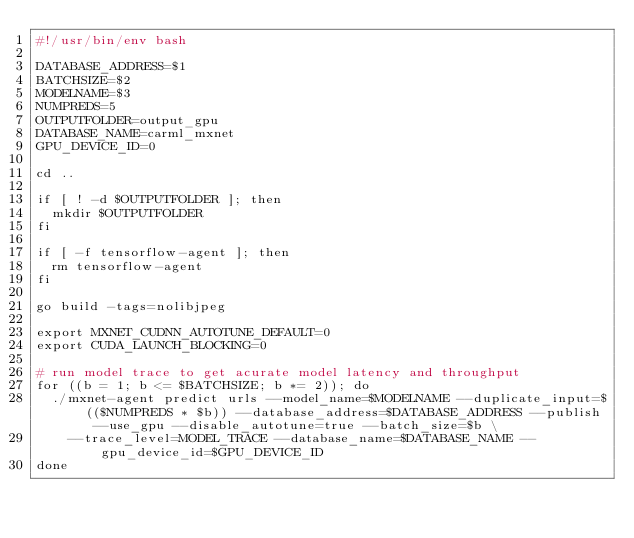<code> <loc_0><loc_0><loc_500><loc_500><_Bash_>#!/usr/bin/env bash

DATABASE_ADDRESS=$1
BATCHSIZE=$2
MODELNAME=$3
NUMPREDS=5
OUTPUTFOLDER=output_gpu
DATABASE_NAME=carml_mxnet
GPU_DEVICE_ID=0

cd ..

if [ ! -d $OUTPUTFOLDER ]; then
  mkdir $OUTPUTFOLDER
fi

if [ -f tensorflow-agent ]; then
  rm tensorflow-agent
fi

go build -tags=nolibjpeg

export MXNET_CUDNN_AUTOTUNE_DEFAULT=0
export CUDA_LAUNCH_BLOCKING=0

# run model trace to get acurate model latency and throughput
for ((b = 1; b <= $BATCHSIZE; b *= 2)); do
  ./mxnet-agent predict urls --model_name=$MODELNAME --duplicate_input=$(($NUMPREDS * $b)) --database_address=$DATABASE_ADDRESS --publish --use_gpu --disable_autotune=true --batch_size=$b \
    --trace_level=MODEL_TRACE --database_name=$DATABASE_NAME --gpu_device_id=$GPU_DEVICE_ID
done
</code> 